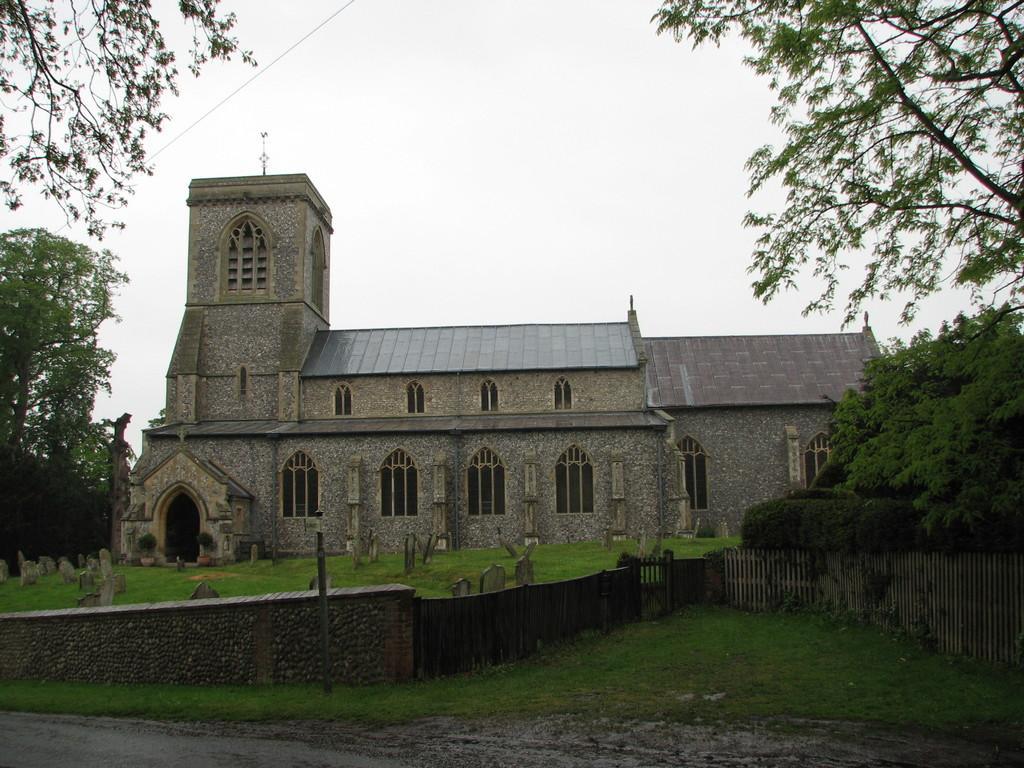Describe this image in one or two sentences. In this image I can see an open grass ground and on it I can see the wall, the gate and number of tombstones. I can also see a building in the background and on the both sides of the image I can see number of trees. On the top side of this image I can see a wire and the sky. 